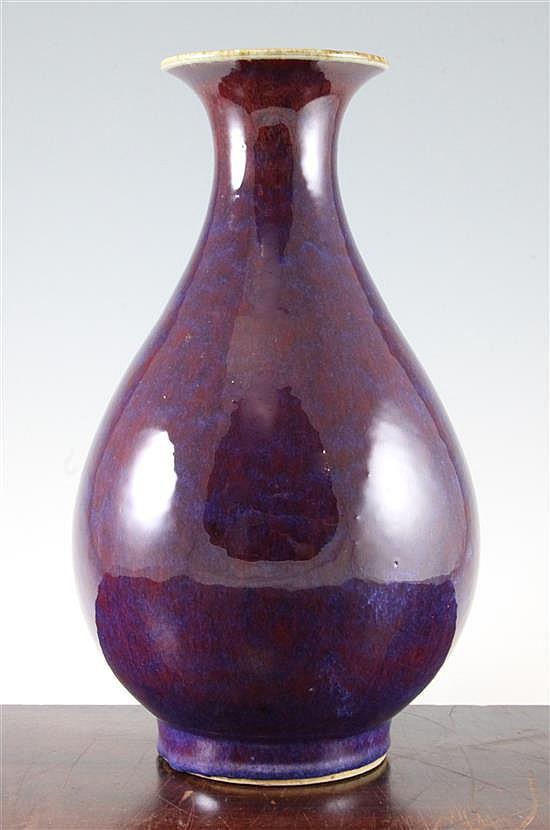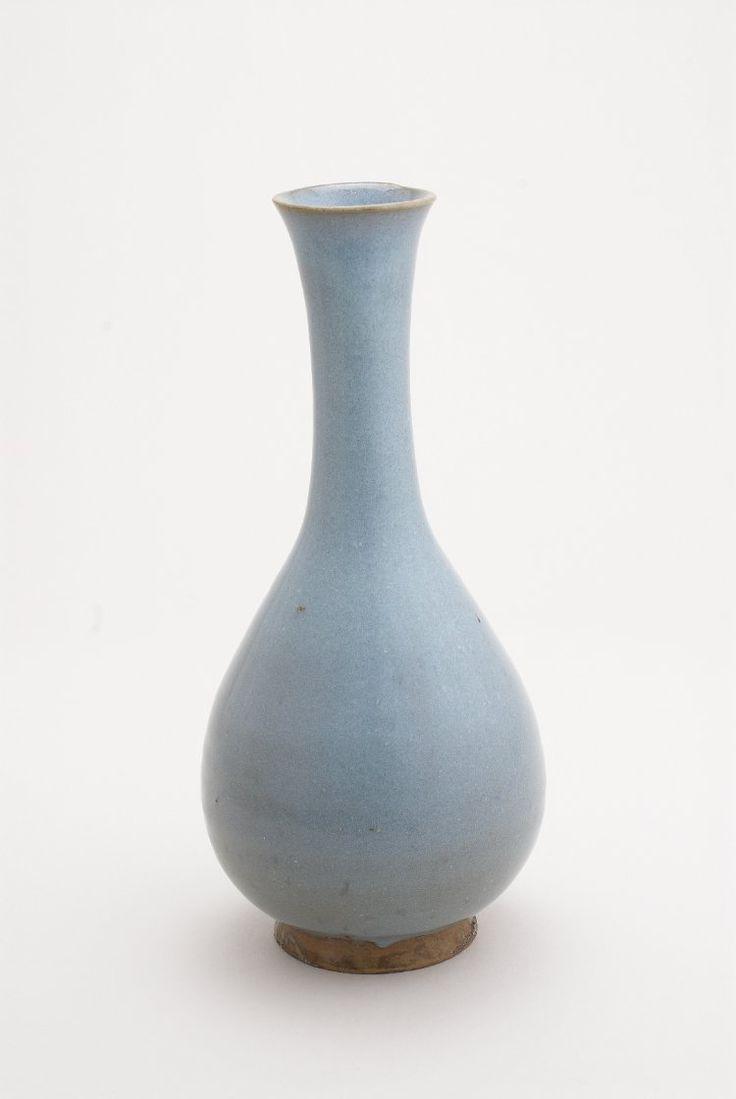The first image is the image on the left, the second image is the image on the right. For the images shown, is this caption "One of the images shows a purple vase while the vase in the other image is mostly blue." true? Answer yes or no. Yes. 